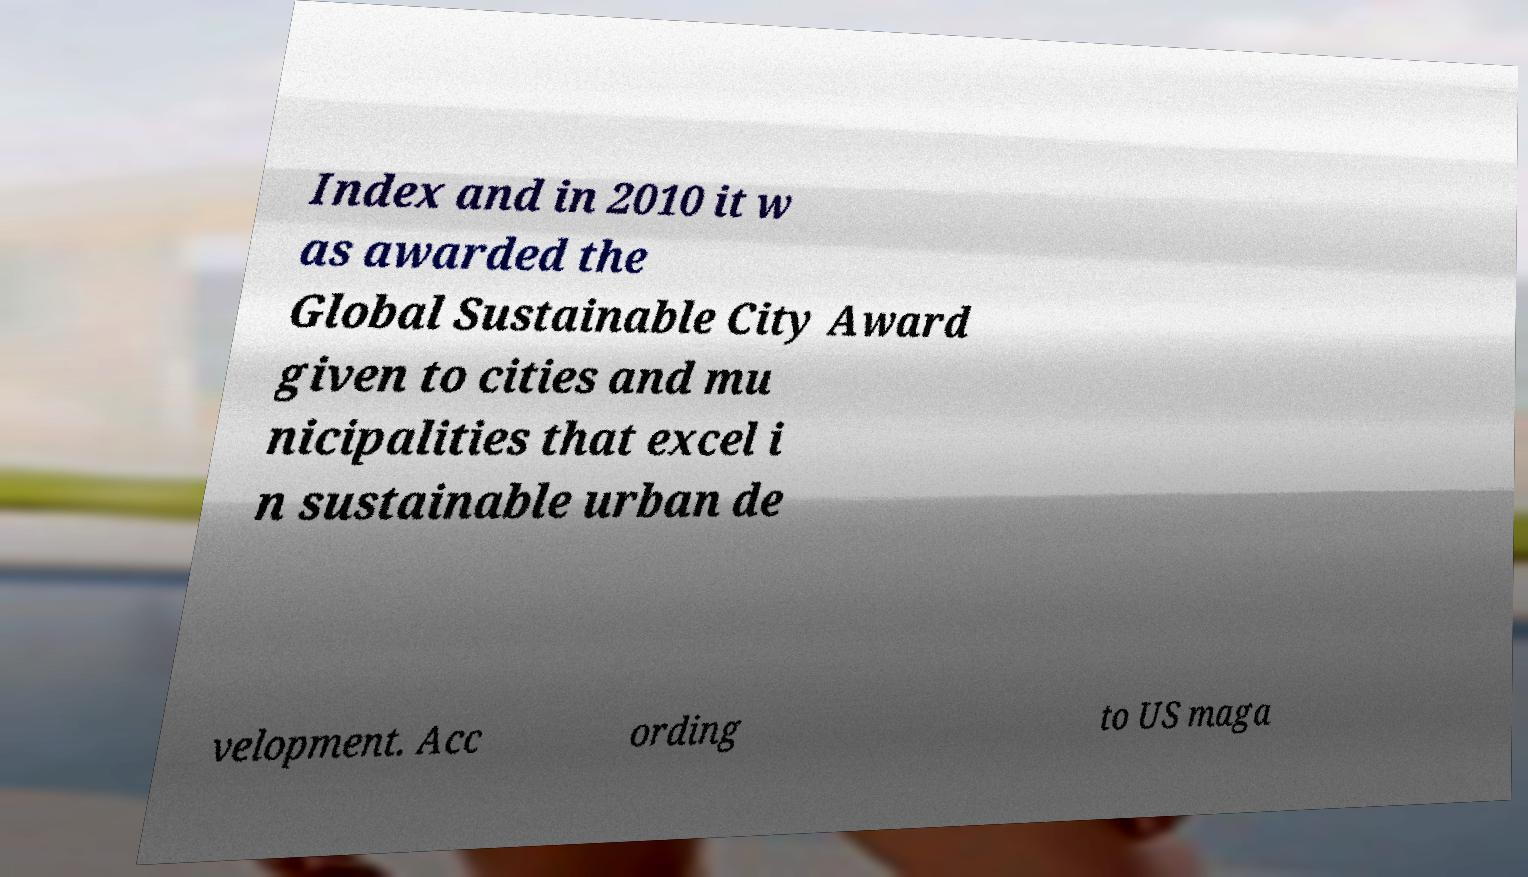Can you read and provide the text displayed in the image?This photo seems to have some interesting text. Can you extract and type it out for me? Index and in 2010 it w as awarded the Global Sustainable City Award given to cities and mu nicipalities that excel i n sustainable urban de velopment. Acc ording to US maga 